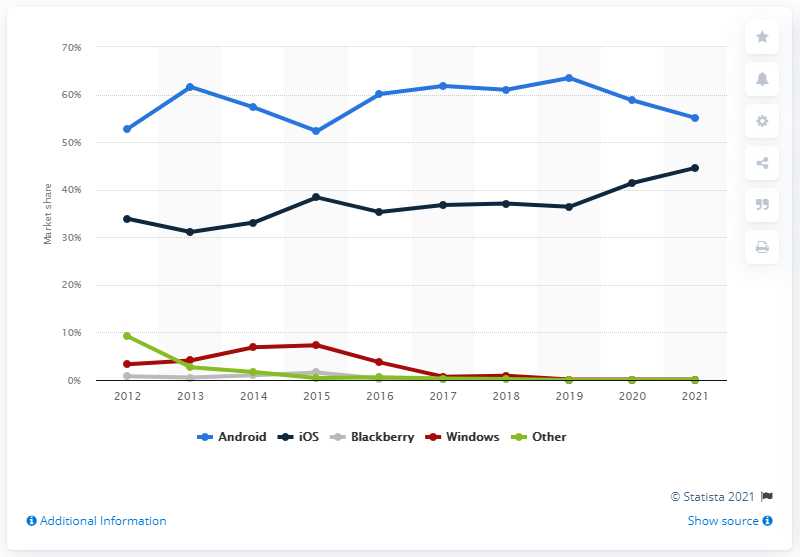Which line represents Android's market share, and what trend does it show? The blue line represents Android's market share, and it shows an increasing trend from 2012 to 2021, with some fluctuations between the years. Can you describe the trend for iOS market share as indicated in the graph? Certainly, the black line represents iOS market share, which overall appears to be on a slight upward trend, hovering around the 30% mark, with minor ups and downs throughout the decade. 